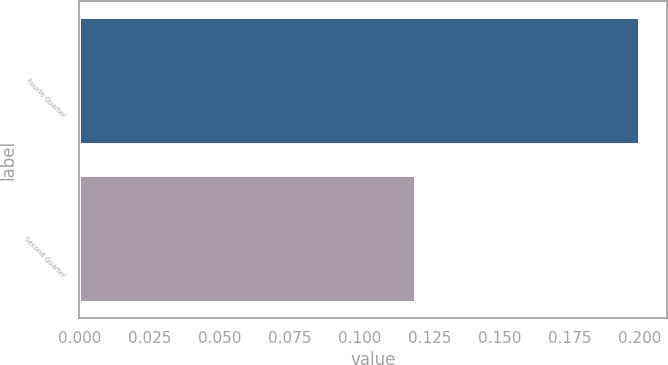Convert chart. <chart><loc_0><loc_0><loc_500><loc_500><bar_chart><fcel>Fourth Quarter<fcel>Second Quarter<nl><fcel>0.2<fcel>0.12<nl></chart> 